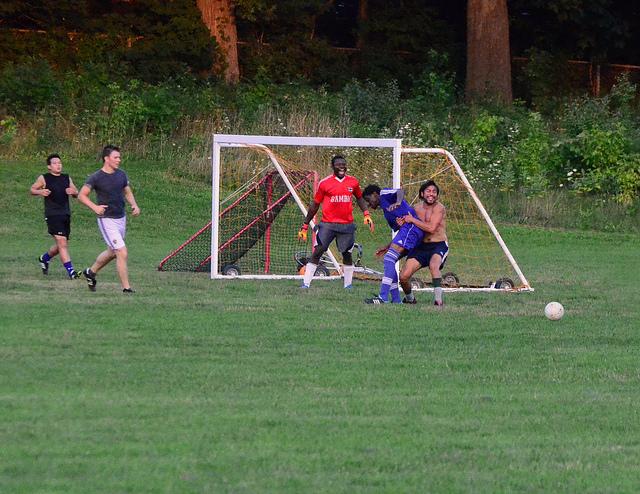Are they playing soccer?
Concise answer only. Yes. What color is the net?
Quick response, please. Orange. What type of field is this?
Write a very short answer. Soccer. Is this a multiracial game?
Answer briefly. Yes. 